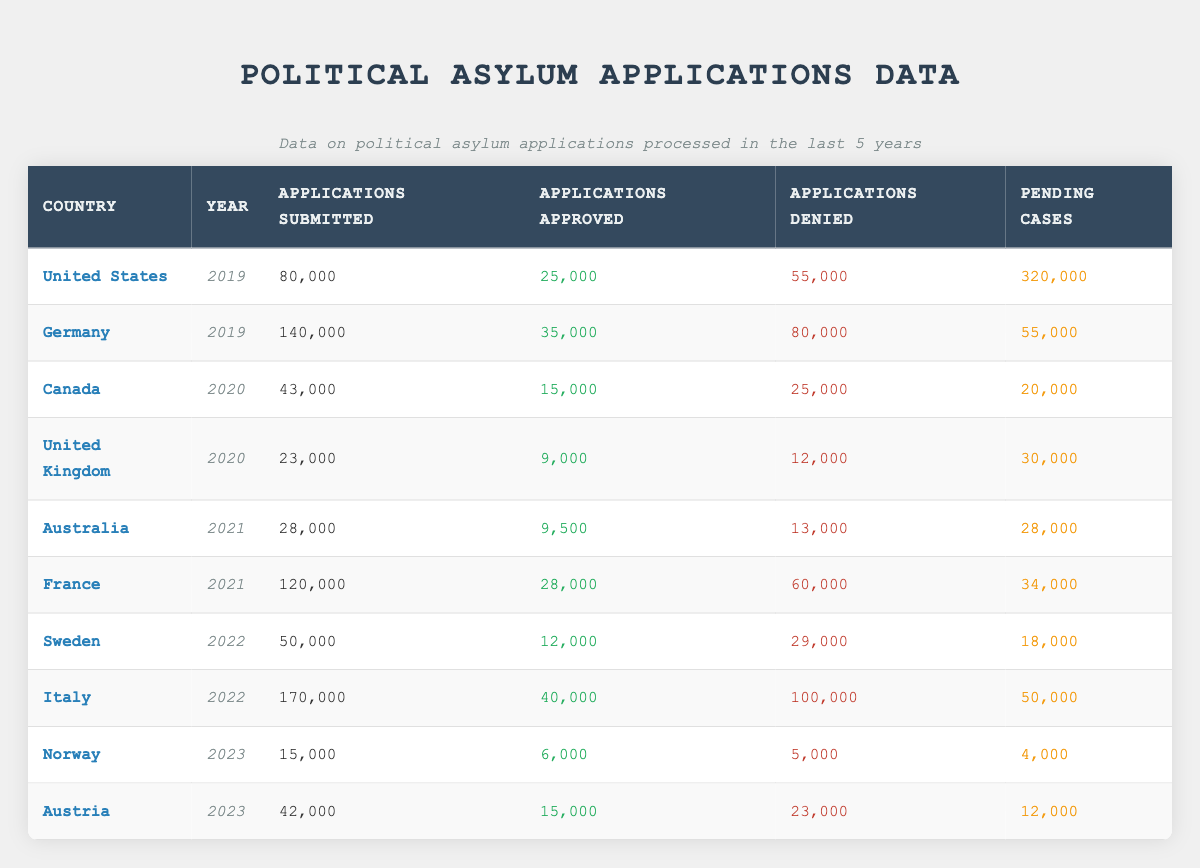What was the total number of applications submitted in Germany in 2019? The table shows that 140,000 applications were submitted in Germany in 2019. This is directly found in the row corresponding to Germany, year 2019, under the column "Applications Submitted."
Answer: 140,000 How many applications were approved in the United States in 2019? According to the table, the United States had 25,000 applications approved in 2019, which can be found in the appropriate row and column of the table.
Answer: 25,000 What is the total number of denied applications across all countries for the year 2022? For 2022, the denied applications are as follows: Sweden (29,000) and Italy (100,000). Adding these gives 29,000 + 100,000 = 129,000 denied applications for that year.
Answer: 129,000 Is it true that Norway had the highest number of applications approved in 2023 compared to Austria? For 2023, Norway approved 6,000 applications, and Austria approved 15,000 applications. Since 15,000 is greater than 6,000, the statement is false.
Answer: No Which country had the highest number of pending cases in 2019? In the data, the United States has 320,000 pending cases, which is the highest when looking at the 2019 row and comparing it with Germany, which had 55,000 pending cases. Thus, the United States had the most pending cases in 2019.
Answer: United States What is the average number of applications submitted in the years 2020 and 2021? The applications submitted were 43,000 (Canada, 2020) and 28,000 (Australia, 2021). The average is calculated as (43,000 + 28,000) / 2 = 35,500.
Answer: 35,500 How many total applications were submitted in 2020 compared to 2021? In 2020, the total applications submitted were 43,000 + 23,000 = 66,000 (Canada & United Kingdom) and in 2021, it was 28,000 + 120,000 = 148,000 (Australia & France). Therefore, 148,000 is greater than 66,000 indicating more applications were submitted in 2021.
Answer: 2021 In which year did Italy have the highest number of applications denied? The table indicates that Italy had 100,000 applications denied in 2022, which is the only entry for Italy, thus it is clear that 2022 is the year with the highest number of denied applications for that country.
Answer: 2022 Was the number of applications approved in France greater than 40,000 during any of the years listed? Referring to the data, the highest number approved was 28,000 in France for the year 2021 which is not greater than 40,000, indicating that the statement is false.
Answer: No 